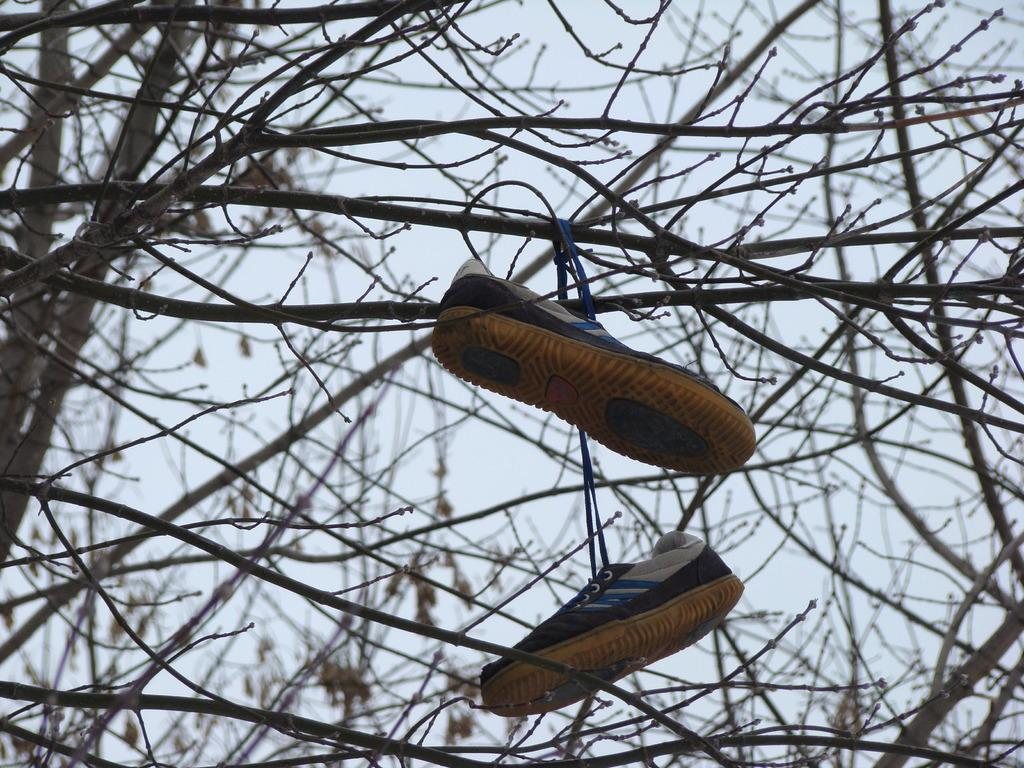What is hanging on the tree in the image? There are shoes hanging on a tree in the image. What is the condition of the tree? The tree appears to be dried. What can be seen in the background of the image? The sky in the background is white. Where is the throne located in the image? There is no throne present in the image. What type of field can be seen in the image? There is no field present in the image. 